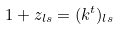Convert formula to latex. <formula><loc_0><loc_0><loc_500><loc_500>1 + z _ { l s } = ( k ^ { t } ) _ { l s }</formula> 